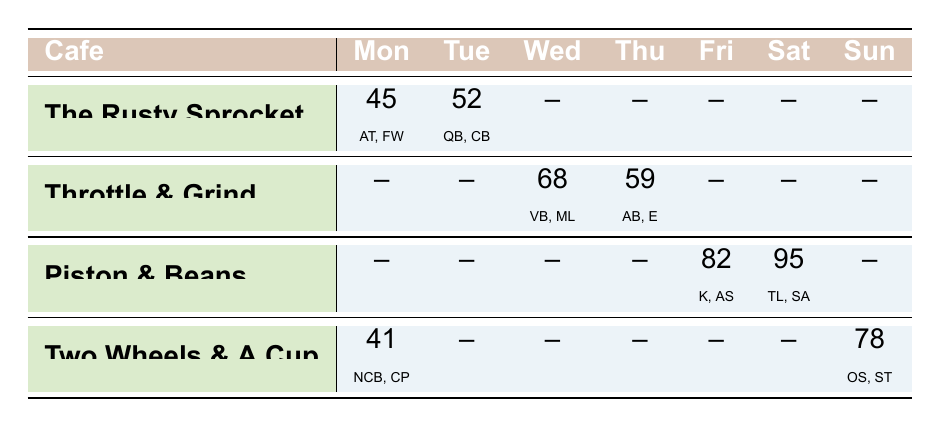What cafe had the highest foot traffic on Saturday? Piston & Beans had the highest foot traffic with 95 people on Saturday, which can be seen in the table where Piston & Beans is listed under Saturday with that foot traffic number.
Answer: Piston & Beans Which menu item sold the most at The Rusty Sprocket on Monday? On Monday, The Rusty Sprocket sold 12 Avocado Toast and 28 Flat White. Comparing these numbers, Flat White sold the most with 28 items.
Answer: Flat White What was the total foot traffic for Two Wheels & A Cup over its operating days? Two Wheels & A Cup is open on Monday (41), and Sunday (78). Adding these values gives 41 + 78 = 119.
Answer: 119 Did Thunder & Grind sell the Vegan Burger more than the Matcha Latte on Wednesday? On Wednesday, Throttle & Grind sold 22 Vegan Burgers and 41 Matcha Lattes. Since 41 is greater than 22, it is false that Vegan Burger sold more.
Answer: No What is the average foot traffic for all cafes on Thursday? The foot traffic on Thursday is 59 for Throttle & Grind. There are no data for other cafes on this day, making average foot traffic simply 59.
Answer: 59 Which cafe had foot traffic on all days except the weekend? The Rusty Sprocket had foot traffic recorded only on Monday and Tuesday, and is not open on the weekend, therefore it applies, and no other cafes had this specific schedule.
Answer: The Rusty Sprocket On which day did Piston & Beans sell more total items than The Rusty Sprocket? Piston & Beans sold 29 Kombuchas and 45 Artisanal Sandwiches on Friday, totaling 74 items, compared to The Rusty Sprocket's total of 12 Avocado Toast and 28 Flat White, totaling 40 items on Monday. Thus, Piston & Beans sold more on Friday.
Answer: Friday Is the combined items sold by Two Wheels & A Cup on Monday greater than that on Sunday? On Monday, Two Wheels & A Cup sold 25 Nitro Cold Brews and 14 Chia Puddings for a total of 39 items. On Sunday, they sold 33 Organic Smoothies and 40 Sourdough Toasts, totaling 73 items. Since 39 is less than 73, the statement is false.
Answer: No 